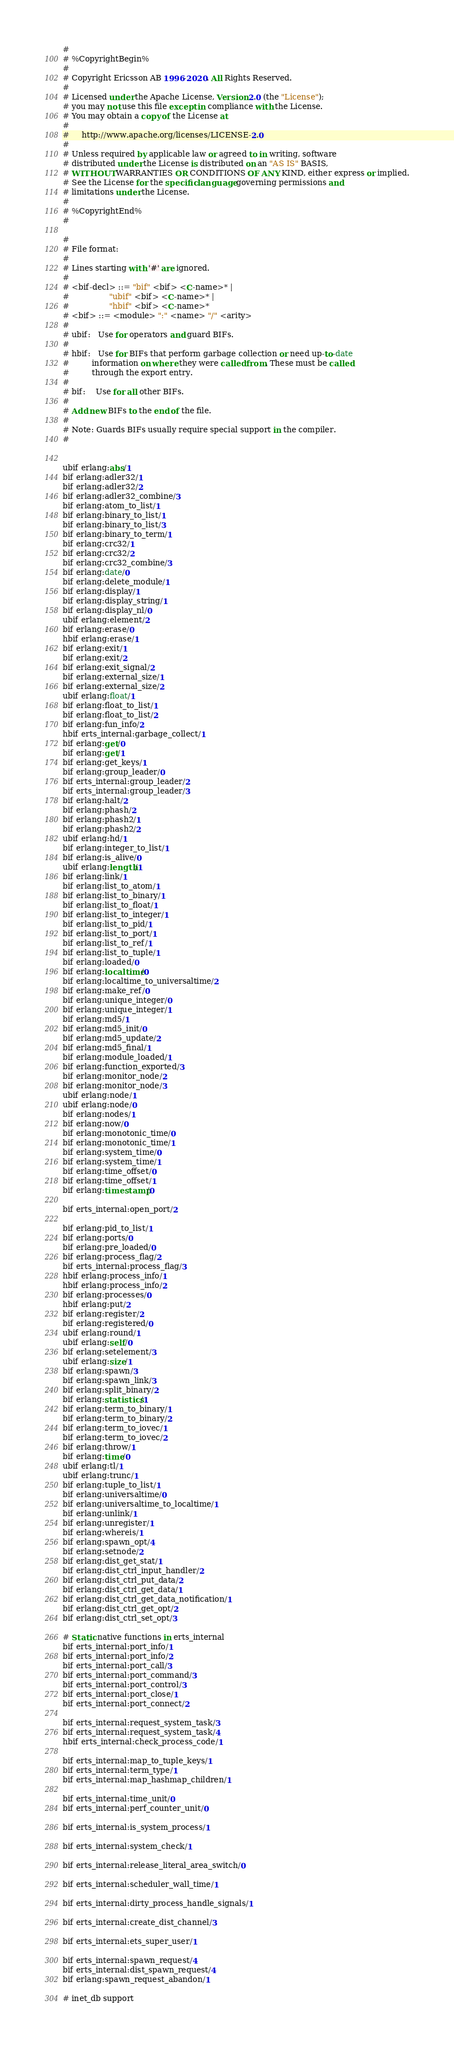<code> <loc_0><loc_0><loc_500><loc_500><_SQL_>#
# %CopyrightBegin%
#
# Copyright Ericsson AB 1996-2020. All Rights Reserved.
#
# Licensed under the Apache License, Version 2.0 (the "License");
# you may not use this file except in compliance with the License.
# You may obtain a copy of the License at
#
#     http://www.apache.org/licenses/LICENSE-2.0
#
# Unless required by applicable law or agreed to in writing, software
# distributed under the License is distributed on an "AS IS" BASIS,
# WITHOUT WARRANTIES OR CONDITIONS OF ANY KIND, either express or implied.
# See the License for the specific language governing permissions and
# limitations under the License.
#
# %CopyrightEnd%
#

#
# File format:
#
# Lines starting with '#' are ignored.
#
# <bif-decl> ::= "bif" <bif> <C-name>* |
#                "ubif" <bif> <C-name>* |
#                "hbif" <bif> <C-name>*
# <bif> ::= <module> ":" <name> "/" <arity>
#
# ubif:   Use for operators and guard BIFs.
#
# hbif:   Use for BIFs that perform garbage collection or need up-to-date
#         information on where they were called from. These must be called
#         through the export entry.
#
# bif:    Use for all other BIFs.
#
# Add new BIFs to the end of the file.
#
# Note: Guards BIFs usually require special support in the compiler.
#


ubif erlang:abs/1
bif erlang:adler32/1
bif erlang:adler32/2
bif erlang:adler32_combine/3
bif erlang:atom_to_list/1
bif erlang:binary_to_list/1
bif erlang:binary_to_list/3
bif erlang:binary_to_term/1
bif erlang:crc32/1
bif erlang:crc32/2
bif erlang:crc32_combine/3
bif erlang:date/0
bif erlang:delete_module/1
bif erlang:display/1
bif erlang:display_string/1
bif erlang:display_nl/0
ubif erlang:element/2
bif erlang:erase/0
hbif erlang:erase/1
bif erlang:exit/1
bif erlang:exit/2
bif erlang:exit_signal/2
bif erlang:external_size/1
bif erlang:external_size/2
ubif erlang:float/1
bif erlang:float_to_list/1
bif erlang:float_to_list/2
bif erlang:fun_info/2
hbif erts_internal:garbage_collect/1
bif erlang:get/0
bif erlang:get/1
bif erlang:get_keys/1
bif erlang:group_leader/0
bif erts_internal:group_leader/2
bif erts_internal:group_leader/3
bif erlang:halt/2
bif erlang:phash/2
bif erlang:phash2/1
bif erlang:phash2/2
ubif erlang:hd/1
bif erlang:integer_to_list/1
bif erlang:is_alive/0
ubif erlang:length/1
bif erlang:link/1
bif erlang:list_to_atom/1
bif erlang:list_to_binary/1
bif erlang:list_to_float/1
bif erlang:list_to_integer/1
bif erlang:list_to_pid/1
bif erlang:list_to_port/1
bif erlang:list_to_ref/1
bif erlang:list_to_tuple/1
bif erlang:loaded/0
bif erlang:localtime/0
bif erlang:localtime_to_universaltime/2
bif erlang:make_ref/0
bif erlang:unique_integer/0
bif erlang:unique_integer/1
bif erlang:md5/1
bif erlang:md5_init/0
bif erlang:md5_update/2
bif erlang:md5_final/1
bif erlang:module_loaded/1
bif erlang:function_exported/3
bif erlang:monitor_node/2
bif erlang:monitor_node/3
ubif erlang:node/1
ubif erlang:node/0
bif erlang:nodes/1
bif erlang:now/0
bif erlang:monotonic_time/0
bif erlang:monotonic_time/1
bif erlang:system_time/0
bif erlang:system_time/1
bif erlang:time_offset/0
bif erlang:time_offset/1
bif erlang:timestamp/0

bif erts_internal:open_port/2

bif erlang:pid_to_list/1
bif erlang:ports/0
bif erlang:pre_loaded/0
bif erlang:process_flag/2
bif erts_internal:process_flag/3
hbif erlang:process_info/1
hbif erlang:process_info/2
bif erlang:processes/0
hbif erlang:put/2
bif erlang:register/2
bif erlang:registered/0
ubif erlang:round/1
ubif erlang:self/0
bif erlang:setelement/3
ubif erlang:size/1
bif erlang:spawn/3
bif erlang:spawn_link/3
bif erlang:split_binary/2
bif erlang:statistics/1
bif erlang:term_to_binary/1
bif erlang:term_to_binary/2
bif erlang:term_to_iovec/1
bif erlang:term_to_iovec/2
bif erlang:throw/1
bif erlang:time/0
ubif erlang:tl/1
ubif erlang:trunc/1
bif erlang:tuple_to_list/1
bif erlang:universaltime/0
bif erlang:universaltime_to_localtime/1
bif erlang:unlink/1
bif erlang:unregister/1
bif erlang:whereis/1
bif erlang:spawn_opt/4
bif erlang:setnode/2
bif erlang:dist_get_stat/1
bif erlang:dist_ctrl_input_handler/2
bif erlang:dist_ctrl_put_data/2
bif erlang:dist_ctrl_get_data/1
bif erlang:dist_ctrl_get_data_notification/1
bif erlang:dist_ctrl_get_opt/2
bif erlang:dist_ctrl_set_opt/3

# Static native functions in erts_internal
bif erts_internal:port_info/1
bif erts_internal:port_info/2
bif erts_internal:port_call/3
bif erts_internal:port_command/3
bif erts_internal:port_control/3
bif erts_internal:port_close/1
bif erts_internal:port_connect/2

bif erts_internal:request_system_task/3
bif erts_internal:request_system_task/4
hbif erts_internal:check_process_code/1

bif erts_internal:map_to_tuple_keys/1
bif erts_internal:term_type/1
bif erts_internal:map_hashmap_children/1

bif erts_internal:time_unit/0
bif erts_internal:perf_counter_unit/0

bif erts_internal:is_system_process/1

bif erts_internal:system_check/1

bif erts_internal:release_literal_area_switch/0

bif erts_internal:scheduler_wall_time/1

bif erts_internal:dirty_process_handle_signals/1

bif erts_internal:create_dist_channel/3

bif erts_internal:ets_super_user/1

bif erts_internal:spawn_request/4
bif erts_internal:dist_spawn_request/4
bif erlang:spawn_request_abandon/1

# inet_db support</code> 